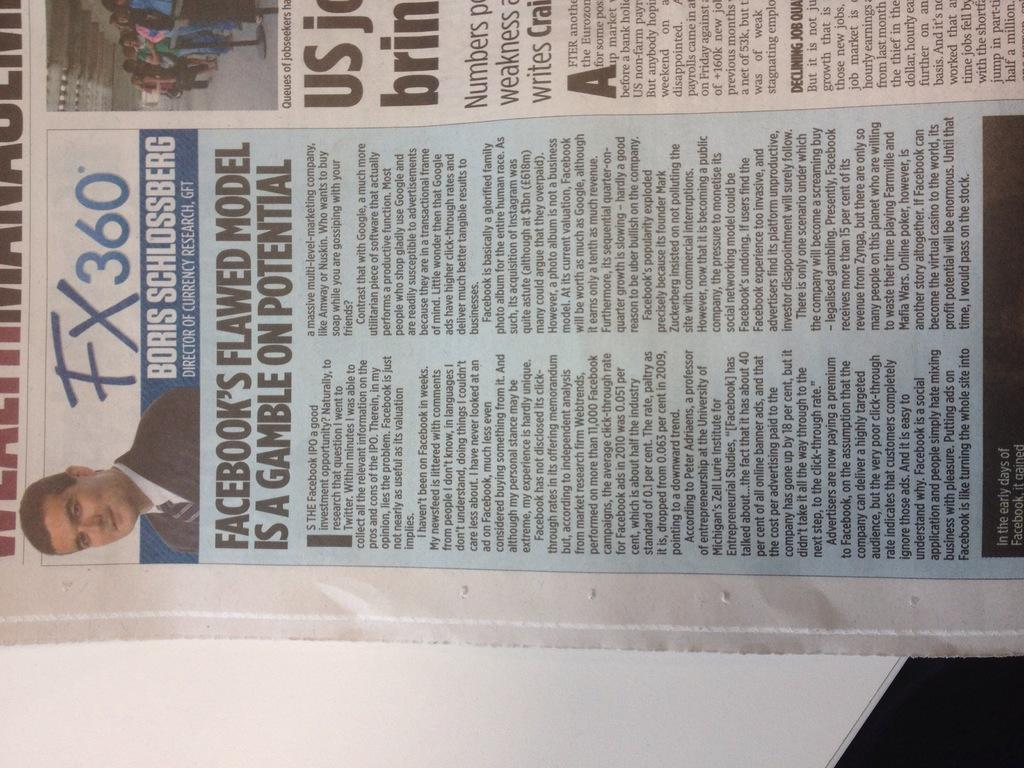What object can be seen in the image? There is a newspaper in the image. Where is the newspaper located? The newspaper is on a table. What can be found on the newspaper? There is writing on the newspaper, including a person in a formal suit and the text "FX 360." What type of credit can be seen on the field in the image? There is no field or credit present in the image; it features a newspaper with writing on it. 